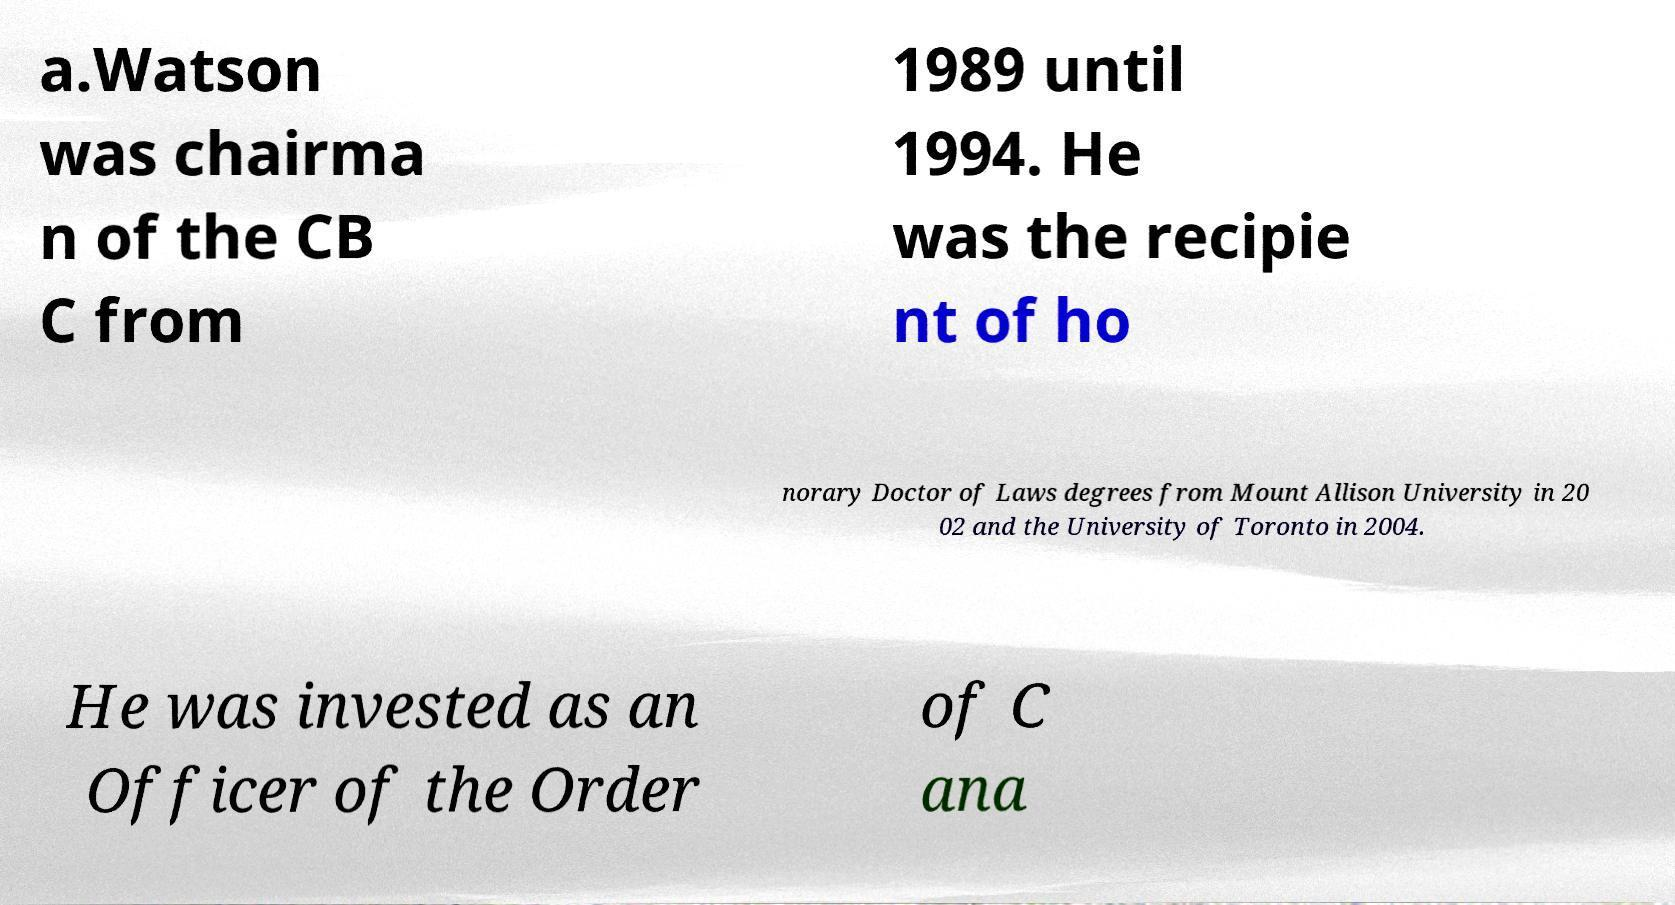There's text embedded in this image that I need extracted. Can you transcribe it verbatim? a.Watson was chairma n of the CB C from 1989 until 1994. He was the recipie nt of ho norary Doctor of Laws degrees from Mount Allison University in 20 02 and the University of Toronto in 2004. He was invested as an Officer of the Order of C ana 